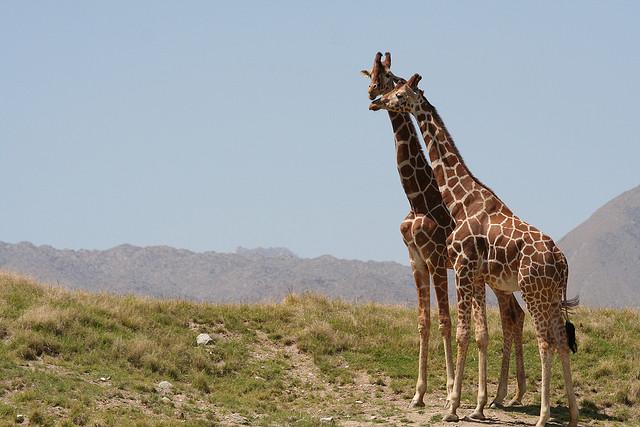How many animals are there?
Answer briefly. 2. What color are their spots?
Answer briefly. Brown. How many species of animals do you see?
Answer briefly. 1. What type of animal is in the picture?
Be succinct. Giraffe. Are they both male?
Be succinct. No. Are the giraffes walking?
Write a very short answer. No. Are the giraffes running?
Be succinct. No. Are the giraffes eating?
Write a very short answer. No. Are these giraffes in the wild?
Short answer required. Yes. How many things are flying in this picture?
Quick response, please. 0. Which animal is younger?
Quick response, please. Giraffe. What is the animal in the bottom right corner?
Short answer required. Giraffe. How many giraffes are seen here?
Be succinct. 2. Are the animals in the wild?
Write a very short answer. Yes. Is it cloudy?
Answer briefly. No. Where are the giraffes?
Quick response, please. Savanna. 